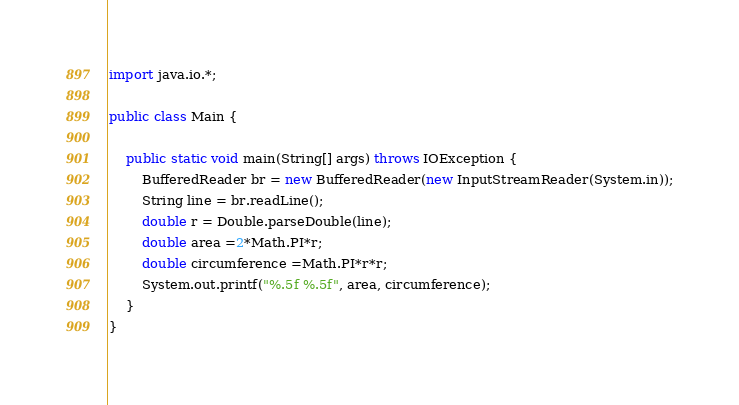Convert code to text. <code><loc_0><loc_0><loc_500><loc_500><_Java_>import java.io.*;

public class Main {

    public static void main(String[] args) throws IOException {
        BufferedReader br = new BufferedReader(new InputStreamReader(System.in));
        String line = br.readLine();
        double r = Double.parseDouble(line);
        double area =2*Math.PI*r;
        double circumference =Math.PI*r*r;
        System.out.printf("%.5f %.5f", area, circumference);
    }
}</code> 